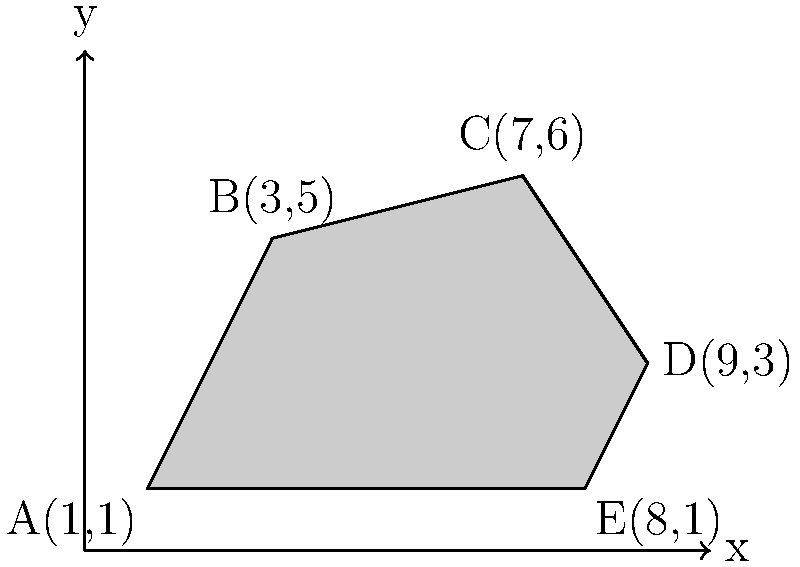In the dark depths of Gotham, Batman has designed an irregularly shaped Batcave. The coordinates of the cave's vertices are A(1,1), B(3,5), C(7,6), D(9,3), and E(8,1). Calculate the area of this secret lair using coordinate geometry. (Hint: Divide the shape into triangles) To find the area of the irregular Batcave, we'll use the following steps:

1. Divide the shape into three triangles: ABC, ACD, and ADE.

2. Calculate the area of each triangle using the formula:
   $$\text{Area}_{\triangle} = \frac{1}{2}|x_1(y_2 - y_3) + x_2(y_3 - y_1) + x_3(y_1 - y_2)|$$

3. For triangle ABC:
   $$\text{Area}_{\triangle ABC} = \frac{1}{2}|1(5 - 6) + 3(6 - 1) + 7(1 - 5)|$$
   $$= \frac{1}{2}|-1 + 15 - 28| = \frac{1}{2}(14) = 7$$

4. For triangle ACD:
   $$\text{Area}_{\triangle ACD} = \frac{1}{2}|1(6 - 3) + 7(3 - 1) + 9(1 - 6)|$$
   $$= \frac{1}{2}|3 + 14 - 45| = \frac{1}{2}(28) = 14$$

5. For triangle ADE:
   $$\text{Area}_{\triangle ADE} = \frac{1}{2}|1(3 - 1) + 9(1 - 1) + 8(1 - 3)|$$
   $$= \frac{1}{2}|2 + 0 - 16| = \frac{1}{2}(14) = 7$$

6. Sum up the areas of all triangles:
   $$\text{Total Area} = 7 + 14 + 7 = 28$$

Therefore, the area of Batman's irregularly shaped Batcave is 28 square units.
Answer: 28 square units 